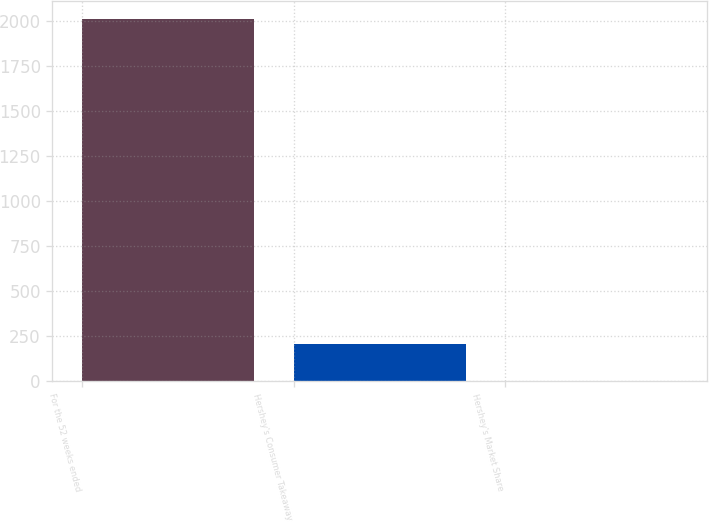<chart> <loc_0><loc_0><loc_500><loc_500><bar_chart><fcel>For the 52 weeks ended<fcel>Hershey's Consumer Takeaway<fcel>Hershey's Market Share<nl><fcel>2012<fcel>201.74<fcel>0.6<nl></chart> 